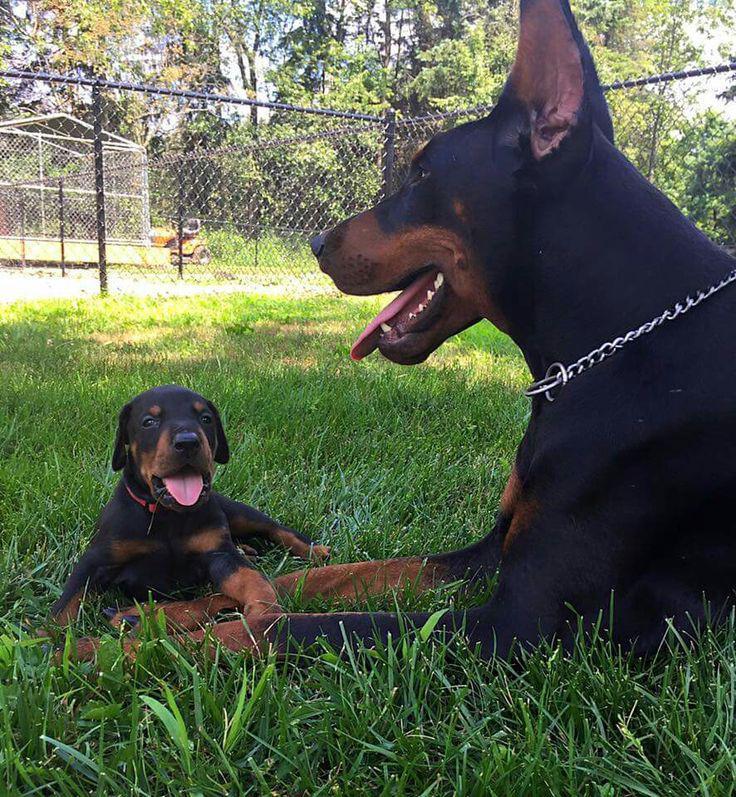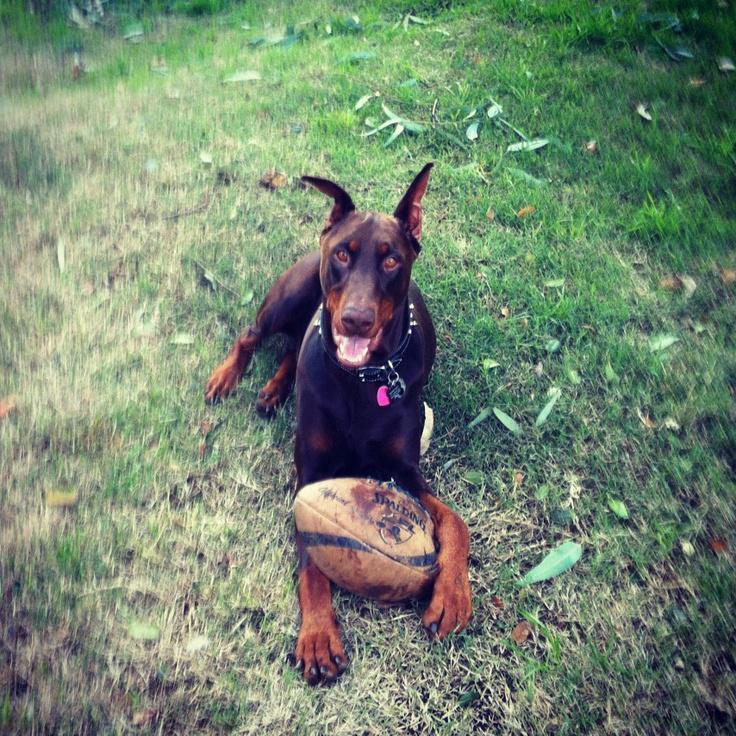The first image is the image on the left, the second image is the image on the right. Evaluate the accuracy of this statement regarding the images: "The left and right image contains the same number of dogs.". Is it true? Answer yes or no. No. The first image is the image on the left, the second image is the image on the right. Considering the images on both sides, is "The left image shows an open-mouthed doberman reclining on the grass by a young 'creature' of some type." valid? Answer yes or no. Yes. 